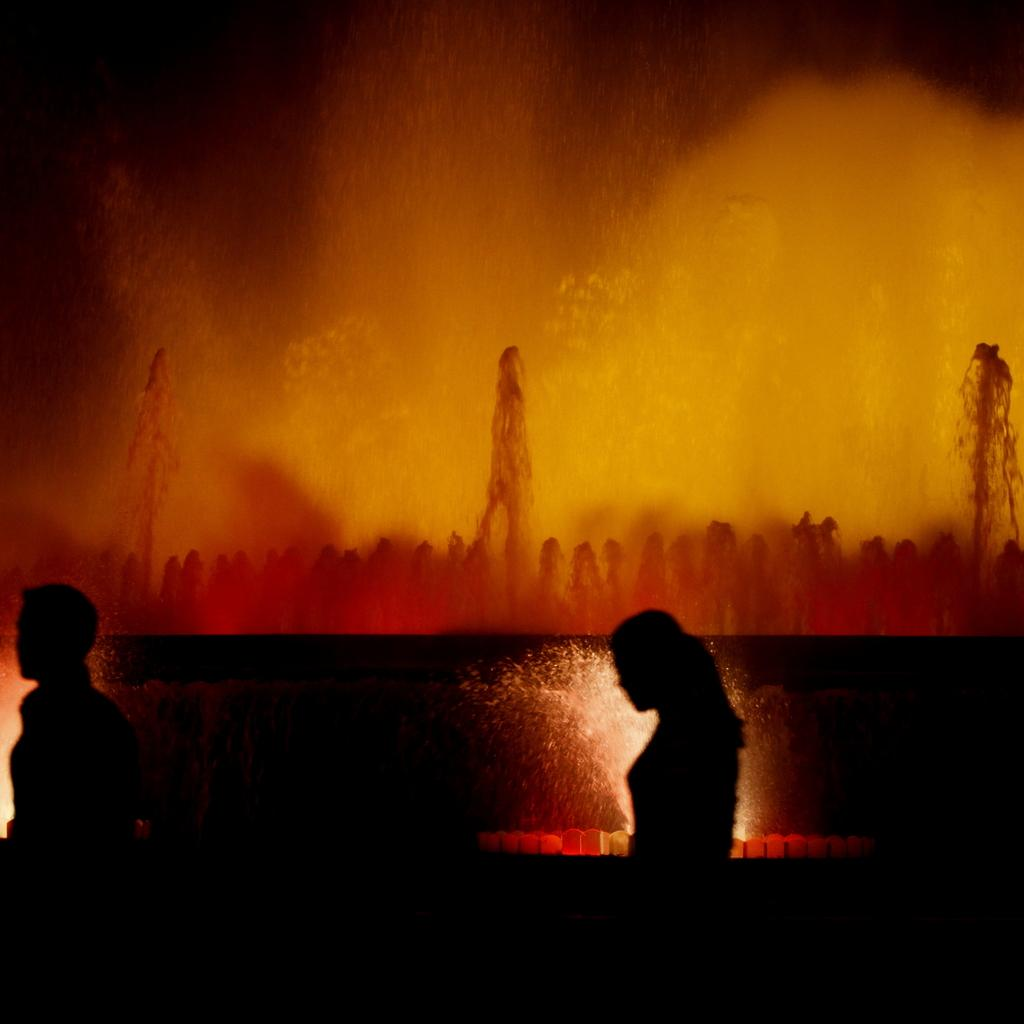How many people are present in the image? There are two persons in the image. Can you describe the painting on the wall in the image? Unfortunately, the facts provided do not give any details about the painting on the wall. What might the two persons be doing in the image? Without additional information, it is impossible to determine what the two persons are doing in the image. What type of coal is being used to create the painting in the image? There is no mention of coal or painting creation in the provided facts, so it is impossible to answer this question. 